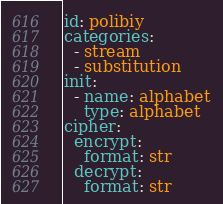Convert code to text. <code><loc_0><loc_0><loc_500><loc_500><_YAML_>id: polibiy
categories:
  - stream
  - substitution
init:
  - name: alphabet
    type: alphabet
cipher:
  encrypt:
    format: str
  decrypt:
    format: str</code> 